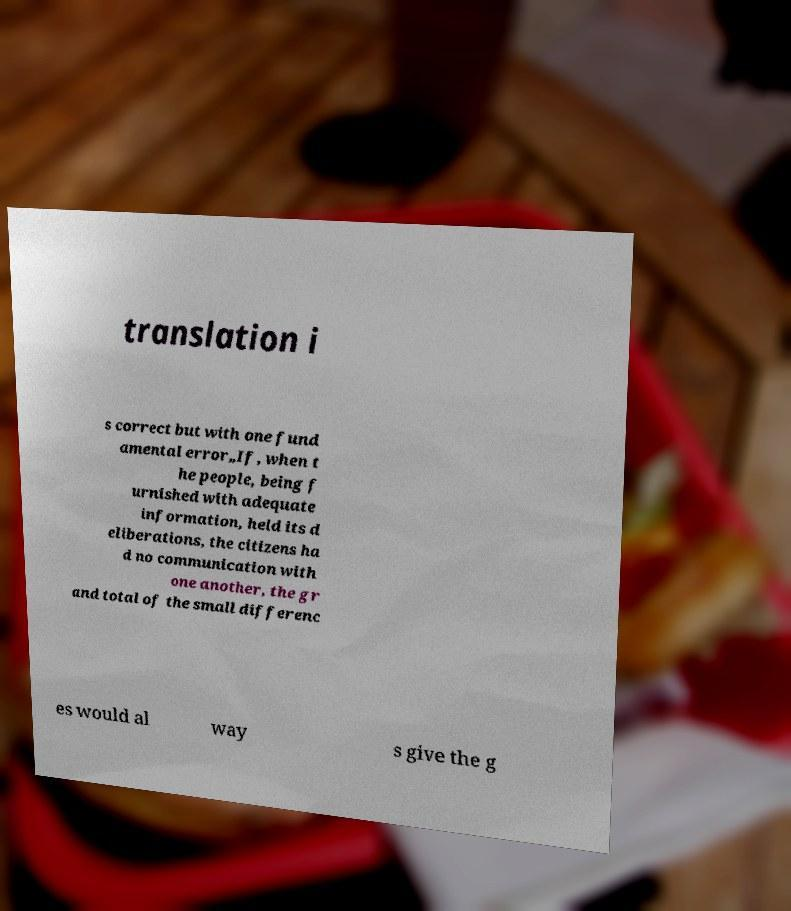Please read and relay the text visible in this image. What does it say? translation i s correct but with one fund amental error„If, when t he people, being f urnished with adequate information, held its d eliberations, the citizens ha d no communication with one another, the gr and total of the small differenc es would al way s give the g 